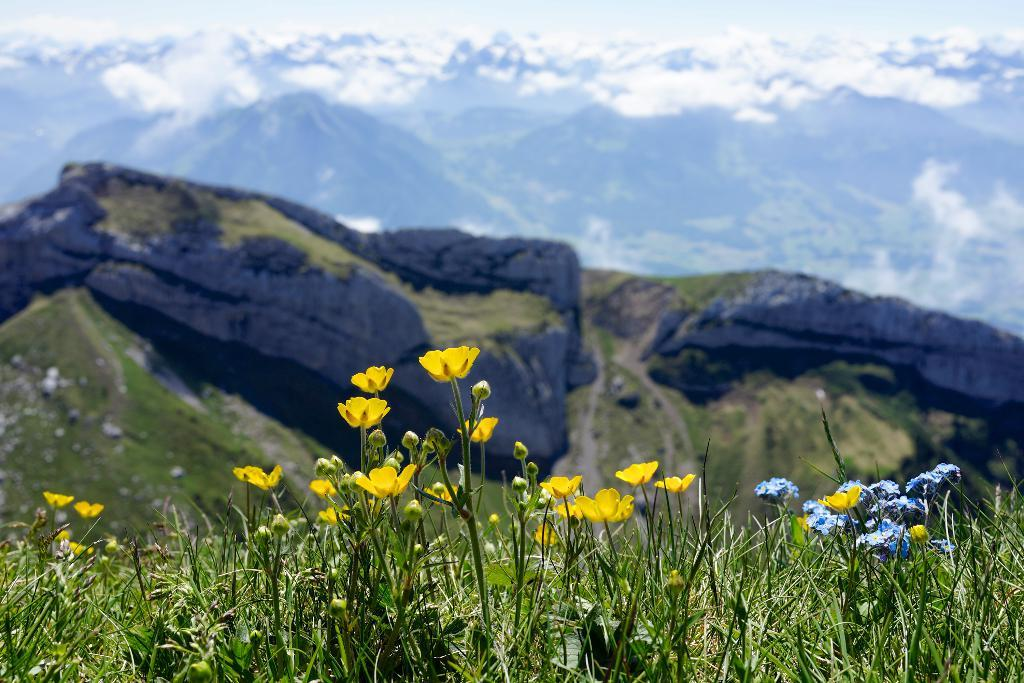What type of plants can be seen in the image? There are plants with flowers and buds in the image. What natural landmark is visible in the image? There are mountains visible in the image. What part of the natural environment is visible in the image? The sky is visible in the background of the image. What type of voice can be heard coming from the plants in the image? There is no voice present in the image, as plants do not have the ability to produce or emit sounds. 